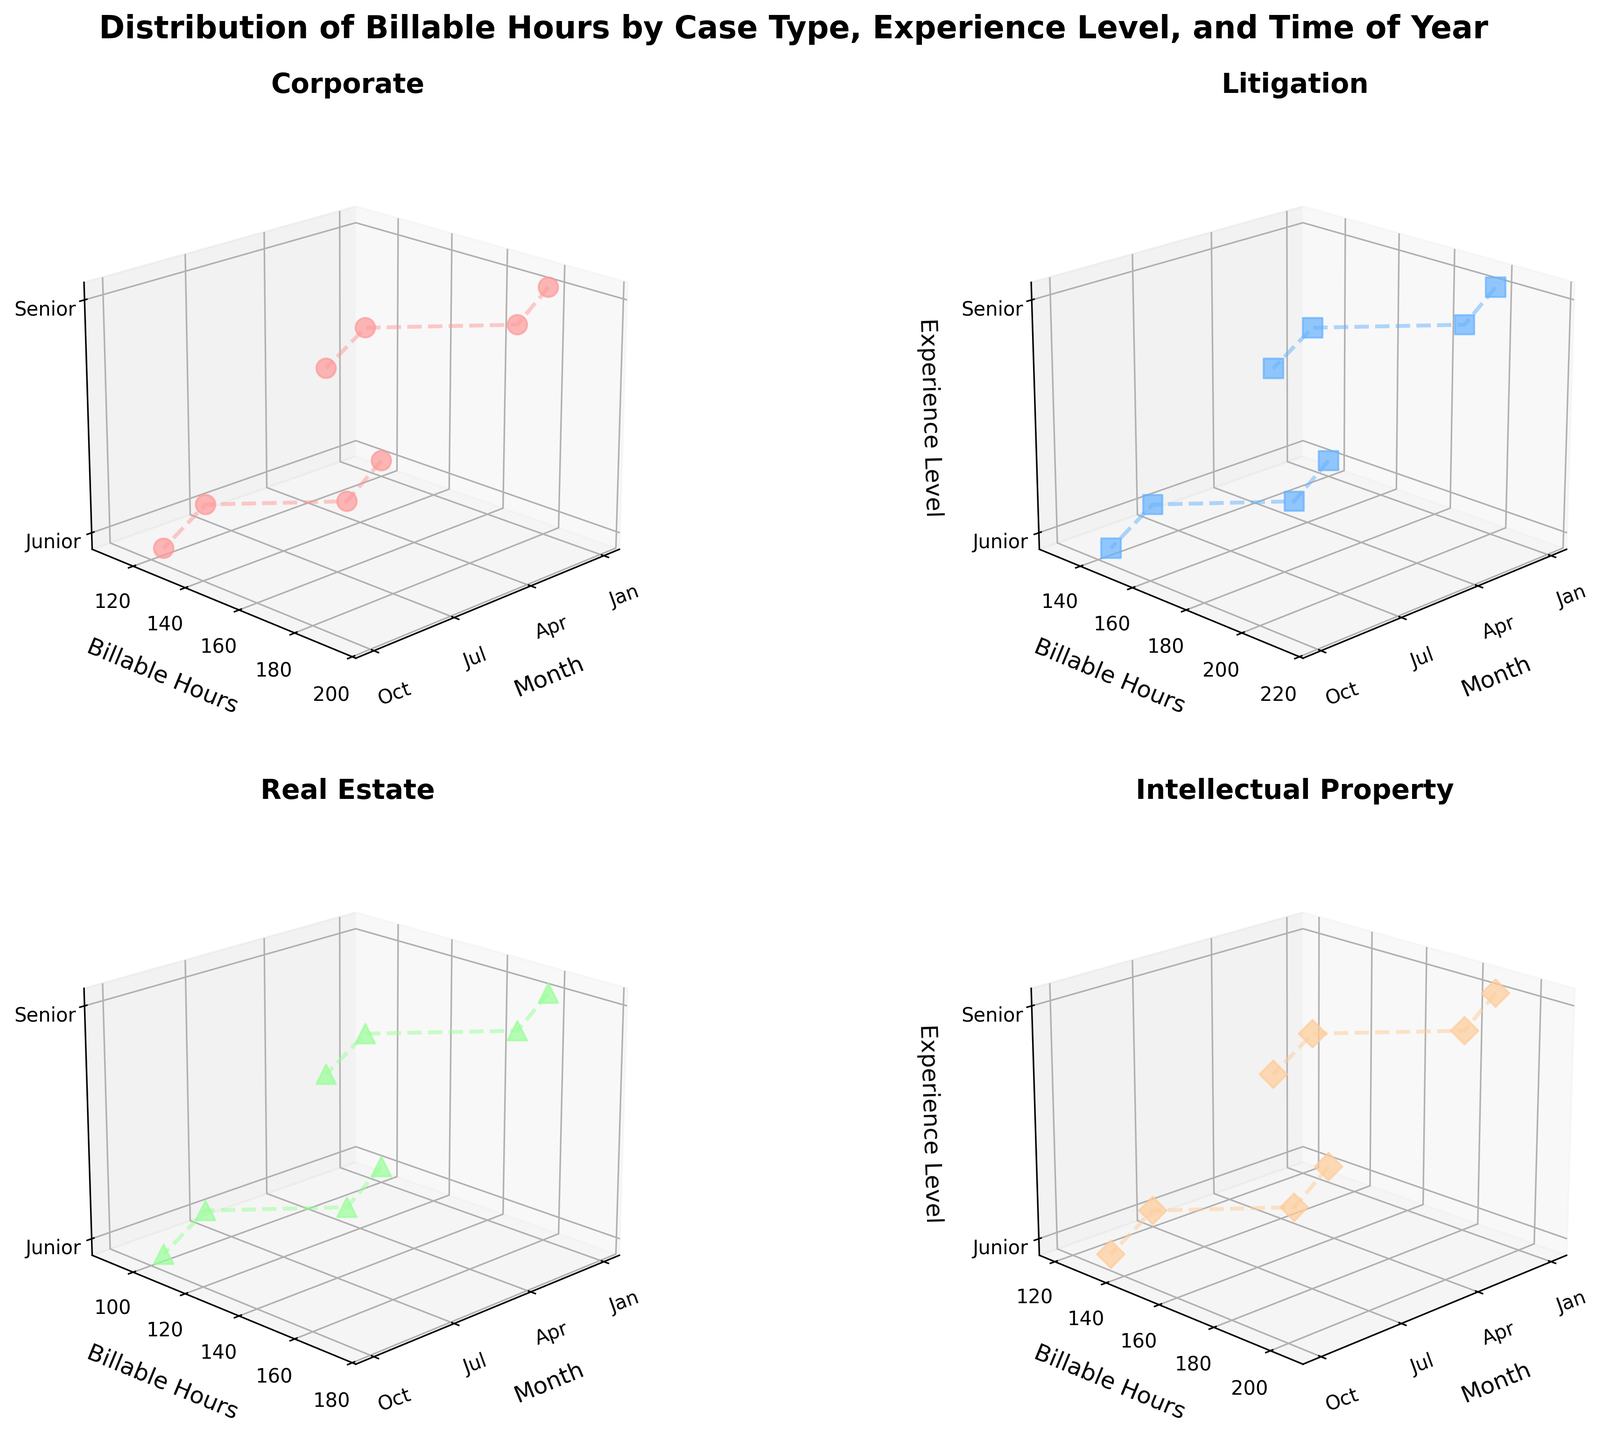what does the figure's title say? The title of the figure is often located at the top and provides an overview of what the visualization is about.
Answer: Distribution of Billable Hours by Case Type, Experience Level, and Time of Year How many subplots are in the figure? By examining the figure, we can count the number of individual plot sections. Each subplot corresponds to a different case type.
Answer: 4 What color represents the Corporate case type in the figure? Each case type is represented by a different color. By looking at the legend or the distinct colors used in one of the subplots, we can identify this.
Answer: Red How do the billable hours for Junior attorneys in Litigation cases change over the months? To answer this question, examine the Litigation subplot and track the billable hours for Junior attorneys across January, April, July, and October.
Answer: Increase from January to April, decreases from April to July, and then increases again from July to October What is the overall trend in billable hours for Senior attorneys across all case types? Look at each subplot to compare how the billable hours of Senior attorneys vary throughout the year for all case types. Notice the general pattern or trend across the months.
Answer: Generally increases throughout the year Which experience level generally has more billable hours for Real Estate cases? Compare the data points of Junior and Senior attorneys in the Real Estate subplot to see which has higher values on average.
Answer: Senior Which case type has the highest billable hours for Junior attorneys in January? Identify the data points for Junior attorneys in each subplot for January, then compare the values to find the highest one.
Answer: Litigation What's the range of billable hours for Senior attorneys in the Intellectual Property case type throughout the year? Find the minimum and maximum billable hours for Senior attorneys in the Intellectual Property subplot and calculate the difference.
Answer: 180 to 205 Are there any case types where Junior attorneys have more billable hours than Senior attorneys? Compare the billable hours of Junior and Senior attorneys in each subplot to see if there's an instance where Junior attorneys outwork Senior ones.
Answer: None 